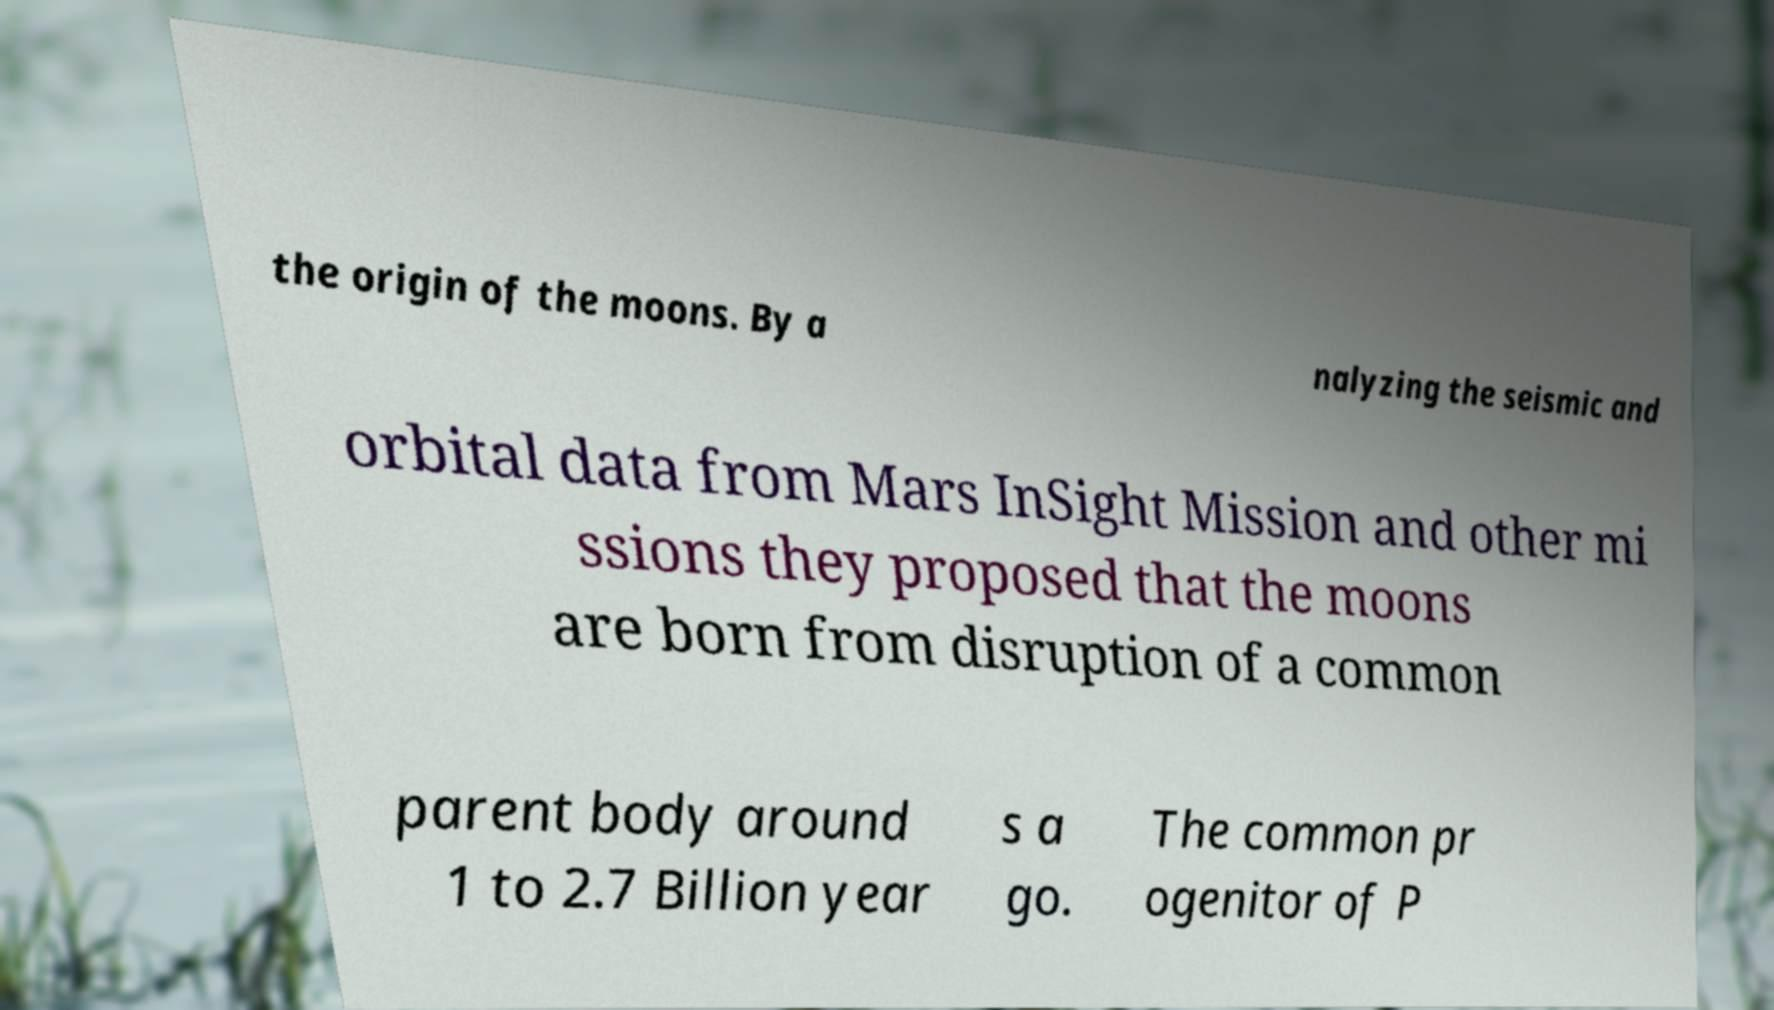For documentation purposes, I need the text within this image transcribed. Could you provide that? the origin of the moons. By a nalyzing the seismic and orbital data from Mars InSight Mission and other mi ssions they proposed that the moons are born from disruption of a common parent body around 1 to 2.7 Billion year s a go. The common pr ogenitor of P 